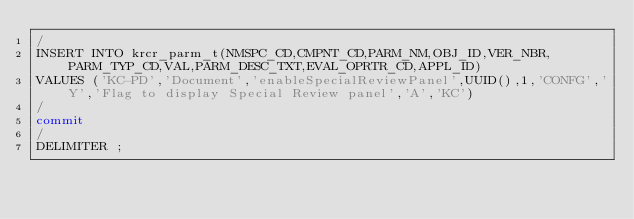<code> <loc_0><loc_0><loc_500><loc_500><_SQL_>/
INSERT INTO krcr_parm_t(NMSPC_CD,CMPNT_CD,PARM_NM,OBJ_ID,VER_NBR,PARM_TYP_CD,VAL,PARM_DESC_TXT,EVAL_OPRTR_CD,APPL_ID)
VALUES ('KC-PD','Document','enableSpecialReviewPanel',UUID(),1,'CONFG','Y','Flag to display Special Review panel','A','KC')
/
commit
/
DELIMITER ;
</code> 